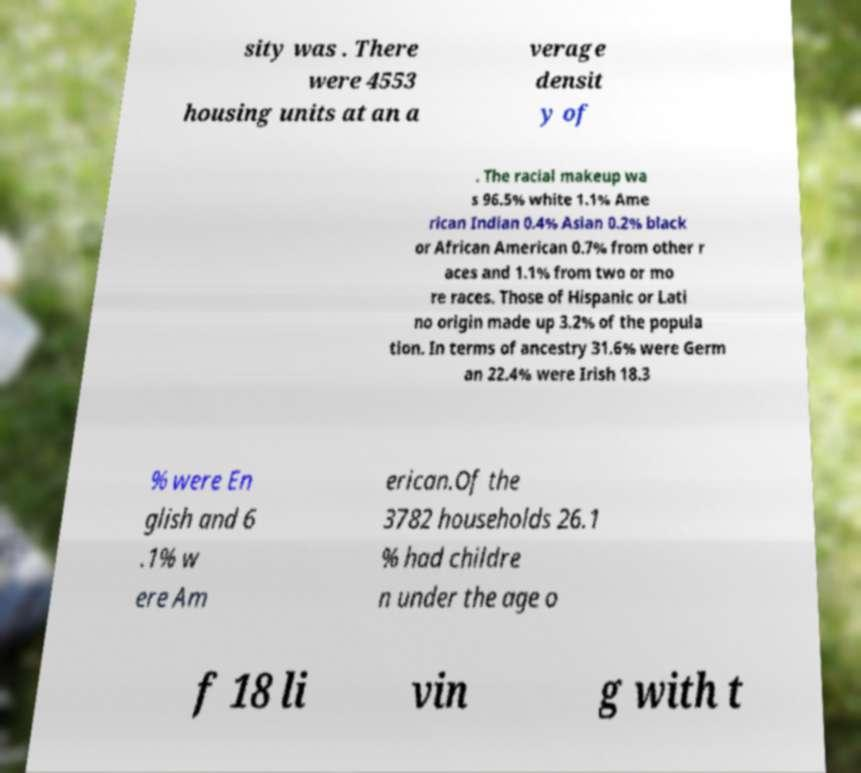Could you extract and type out the text from this image? sity was . There were 4553 housing units at an a verage densit y of . The racial makeup wa s 96.5% white 1.1% Ame rican Indian 0.4% Asian 0.2% black or African American 0.7% from other r aces and 1.1% from two or mo re races. Those of Hispanic or Lati no origin made up 3.2% of the popula tion. In terms of ancestry 31.6% were Germ an 22.4% were Irish 18.3 % were En glish and 6 .1% w ere Am erican.Of the 3782 households 26.1 % had childre n under the age o f 18 li vin g with t 